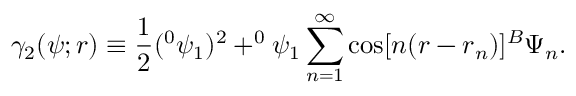<formula> <loc_0><loc_0><loc_500><loc_500>\gamma _ { 2 } ( \psi ; r ) \equiv \frac { 1 } { 2 } ( ^ { 0 } \psi _ { 1 } ) ^ { 2 } + ^ { 0 } \psi _ { 1 } \sum _ { n = 1 } ^ { \infty } \cos [ n ( r - r _ { n } ) ] ^ { B } \Psi _ { n } .</formula> 